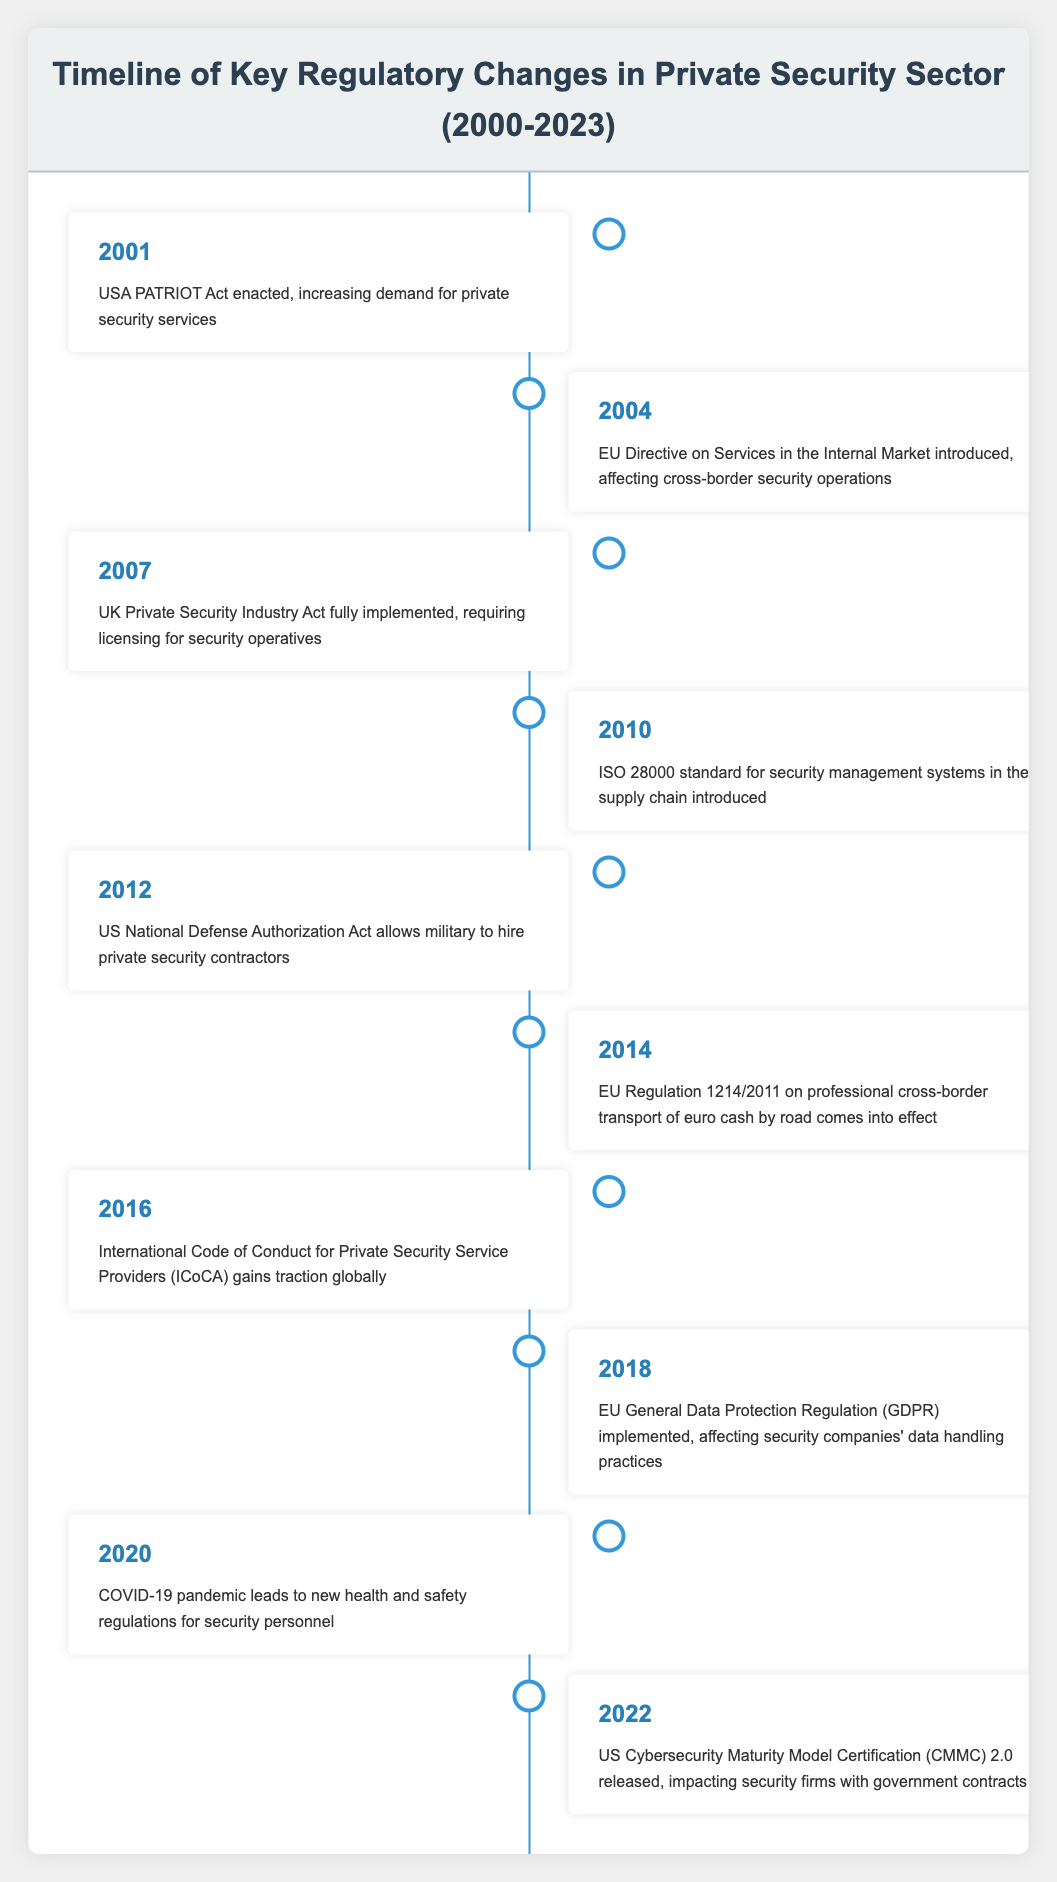What event introduced new regulations affecting cross-border security operations? Referring to the table, the event that introduced new regulations for cross-border security operations is noted in 2004 as the "EU Directive on Services in the Internal Market."
Answer: EU Directive on Services in the Internal Market How many significant regulatory changes occurred between 2000 and 2010? By looking at the years listed in the table, the events that occurred between 2000 and 2010 are: 2001, 2004, 2007, and 2010, which sums up to four events.
Answer: 4 Was the USA PATRIOT Act enacted before or after the 2007 UK Private Security Industry Act? The USA PATRIOT Act is listed under the year 2001, while the UK Private Security Industry Act is under 2007. Since 2001 is before 2007, the USA PATRIOT Act was enacted before the UK Private Security Industry Act.
Answer: Before What is the average year of implementation for the regulations between 2010 and 2022? The relevant years for regulations between 2010 and 2022 are: 2010, 2012, 2014, 2016, 2018, 2020, and 2022. To find the average, first, sum the years (2010 + 2012 + 2014 + 2016 + 2018 + 2020 + 2022 = 1412) and divide by the number of events (7). Thus, the average is 1412/7 = 201.71, rounded to 2019.
Answer: 2019 Did the GDPR have an impact on data handling practices for security companies? The table explicitly mentions that the "EU General Data Protection Regulation (GDPR) implemented, affecting security companies' data handling practices" in 2018. Therefore, yes, GDPR had an impact.
Answer: Yes What trends can be identified in the regulatory changes from 2000 to 2023? Analyzing the timeline, we can see a trend towards strengthening regulations within the private security sector, including improvements in data protection (GDPR), health and safety standards (COVID-19 regulations), and licensing (UK Private Security Industry Act). Additionally, the rise of cybersecurity concerns is notable with the introduction of the CMMC 2.0 in 2022, reflecting an evolving landscape.
Answer: Strengthening regulations and focus on data protection and cybersecurity Which year's event involved the implementation of health and safety regulations due to a pandemic? The event regarding the pandemic's impact on health and safety regulations for security personnel is listed in 2020.
Answer: 2020 Is the International Code of Conduct for Private Security Service Providers recognized globally? The table indicates that the International Code of Conduct for Private Security Service Providers (ICoCA) gained traction globally in 2016, confirming its recognition worldwide.
Answer: Yes 